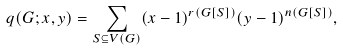<formula> <loc_0><loc_0><loc_500><loc_500>q ( G ; x , y ) & = \sum _ { S \subseteq V ( G ) } ( x - 1 ) ^ { r ( G [ S ] ) } ( y - 1 ) ^ { n ( G [ S ] ) } ,</formula> 